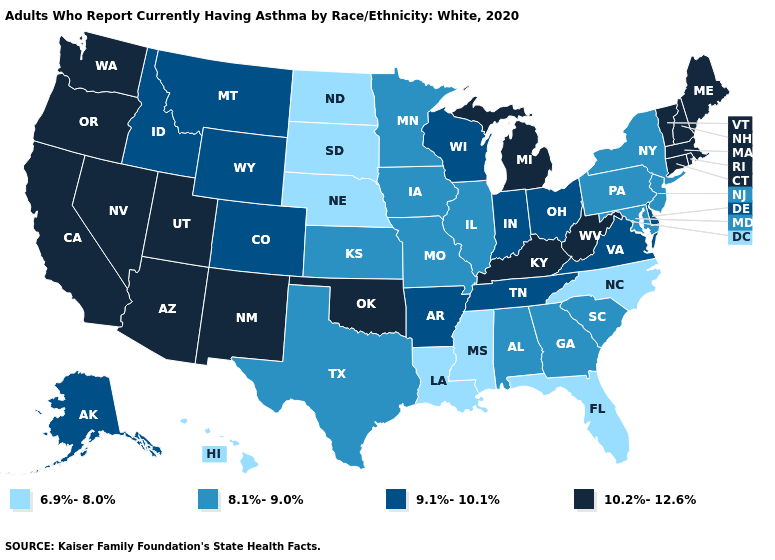Does Mississippi have the lowest value in the USA?
Answer briefly. Yes. Name the states that have a value in the range 9.1%-10.1%?
Give a very brief answer. Alaska, Arkansas, Colorado, Delaware, Idaho, Indiana, Montana, Ohio, Tennessee, Virginia, Wisconsin, Wyoming. Among the states that border West Virginia , which have the highest value?
Be succinct. Kentucky. Does the first symbol in the legend represent the smallest category?
Keep it brief. Yes. Does Wyoming have the lowest value in the West?
Give a very brief answer. No. What is the value of Oklahoma?
Short answer required. 10.2%-12.6%. What is the value of Louisiana?
Quick response, please. 6.9%-8.0%. How many symbols are there in the legend?
Quick response, please. 4. How many symbols are there in the legend?
Answer briefly. 4. Among the states that border Idaho , which have the lowest value?
Quick response, please. Montana, Wyoming. What is the value of Louisiana?
Write a very short answer. 6.9%-8.0%. What is the value of Arizona?
Write a very short answer. 10.2%-12.6%. Among the states that border Arizona , does Colorado have the highest value?
Quick response, please. No. What is the value of Kansas?
Give a very brief answer. 8.1%-9.0%. 